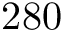Convert formula to latex. <formula><loc_0><loc_0><loc_500><loc_500>2 8 0</formula> 